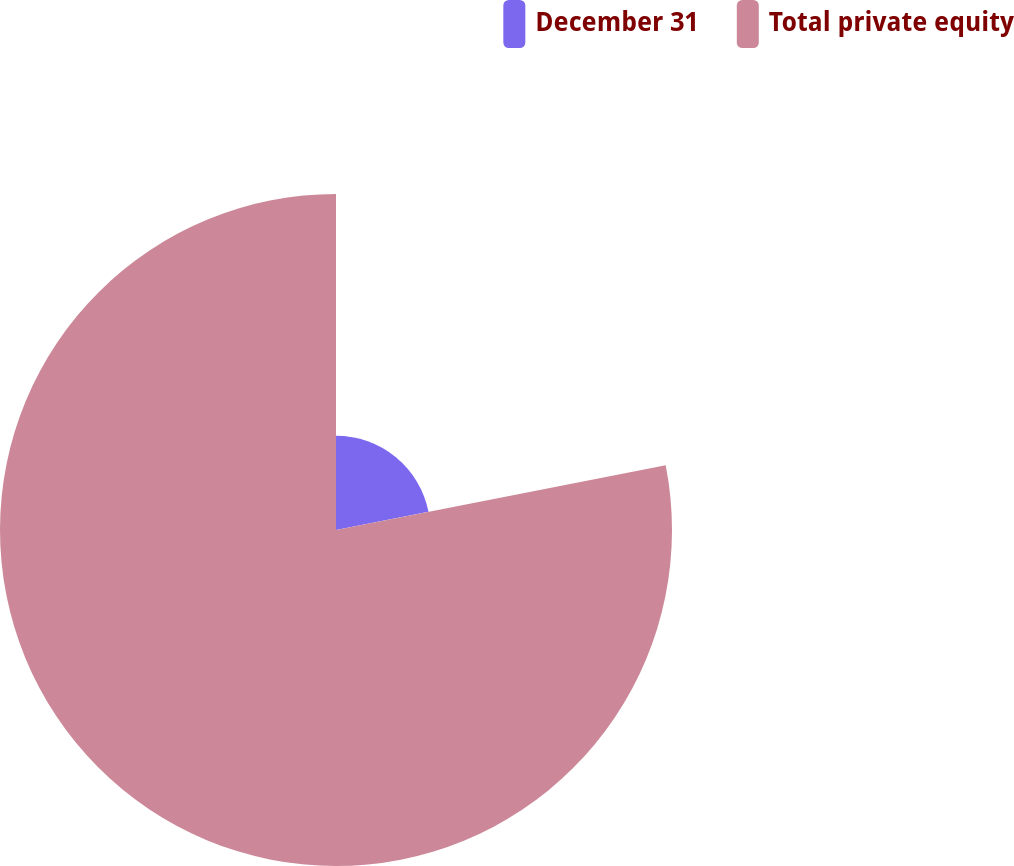Convert chart to OTSL. <chart><loc_0><loc_0><loc_500><loc_500><pie_chart><fcel>December 31<fcel>Total private equity<nl><fcel>21.91%<fcel>78.09%<nl></chart> 